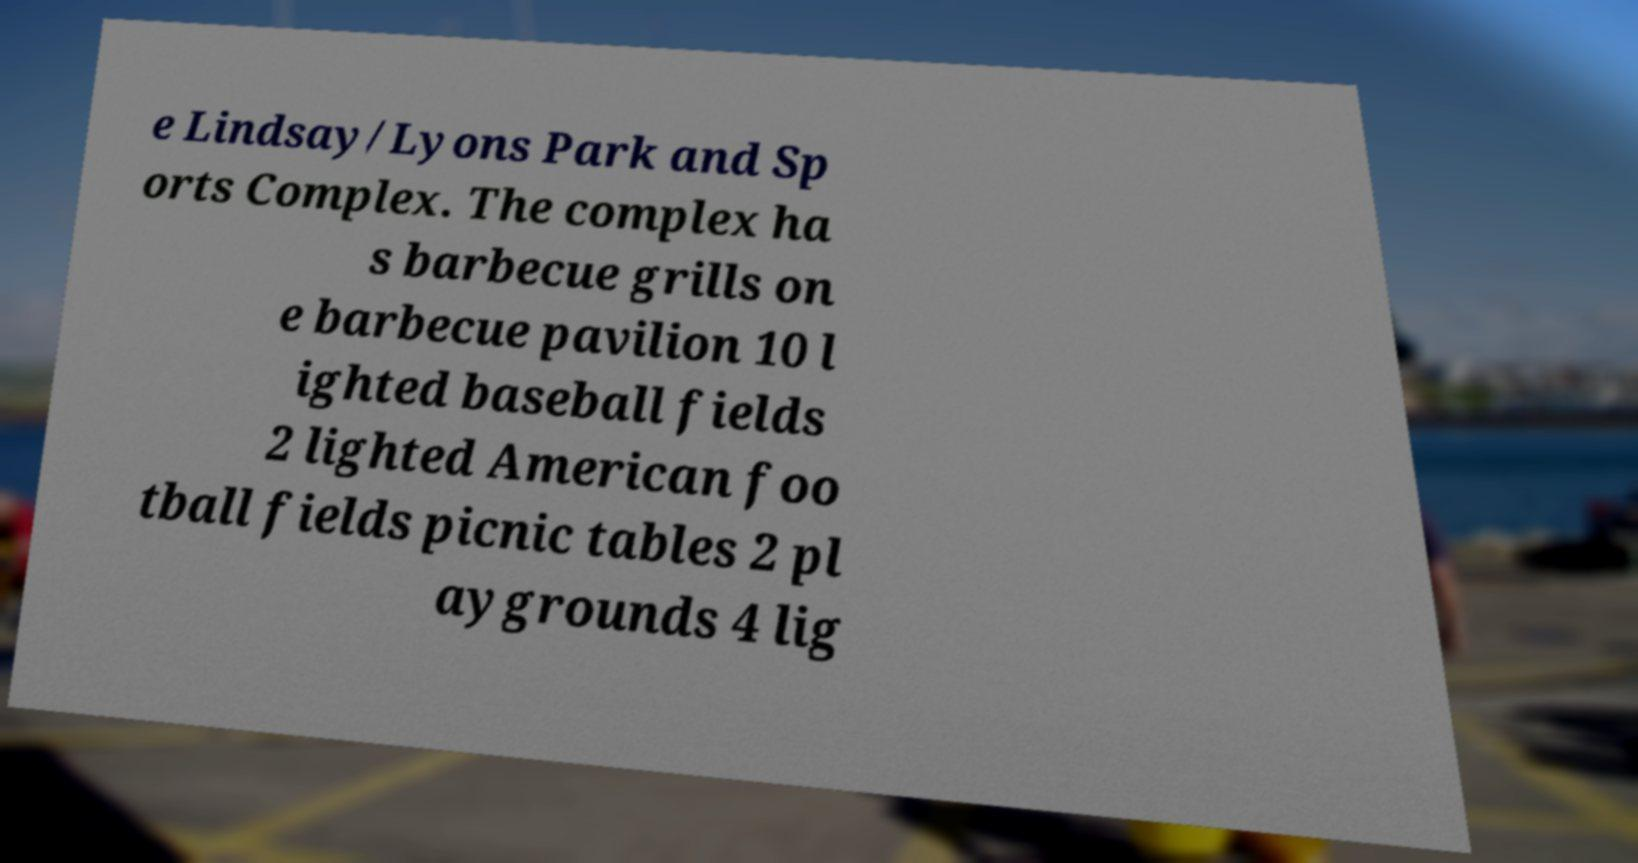For documentation purposes, I need the text within this image transcribed. Could you provide that? e Lindsay/Lyons Park and Sp orts Complex. The complex ha s barbecue grills on e barbecue pavilion 10 l ighted baseball fields 2 lighted American foo tball fields picnic tables 2 pl aygrounds 4 lig 